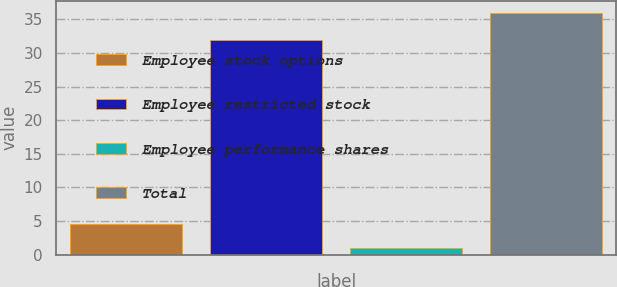Convert chart to OTSL. <chart><loc_0><loc_0><loc_500><loc_500><bar_chart><fcel>Employee stock options<fcel>Employee restricted stock<fcel>Employee performance shares<fcel>Total<nl><fcel>4.5<fcel>32<fcel>1<fcel>36<nl></chart> 